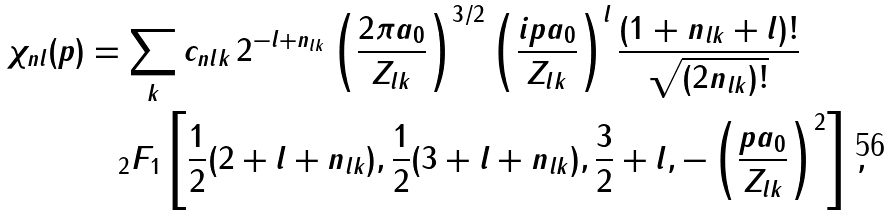<formula> <loc_0><loc_0><loc_500><loc_500>\chi _ { n l } ( p ) & = \sum _ { k } c _ { n l k } \, 2 ^ { - l + n _ { l k } } \left ( \frac { 2 \pi a _ { 0 } } { Z _ { l k } } \right ) ^ { 3 / 2 } \left ( \frac { i p a _ { 0 } } { Z _ { l k } } \right ) ^ { l } \frac { ( 1 + n _ { l k } + l ) ! } { \sqrt { ( 2 n _ { l k } ) ! } } \, \\ & \quad _ { 2 } F _ { 1 } \left [ \frac { 1 } { 2 } ( 2 + l + n _ { l k } ) , \frac { 1 } { 2 } ( 3 + l + n _ { l k } ) , \frac { 3 } { 2 } + l , - \left ( \frac { p a _ { 0 } } { Z _ { l k } } \right ) ^ { 2 } \right ] \, ,</formula> 